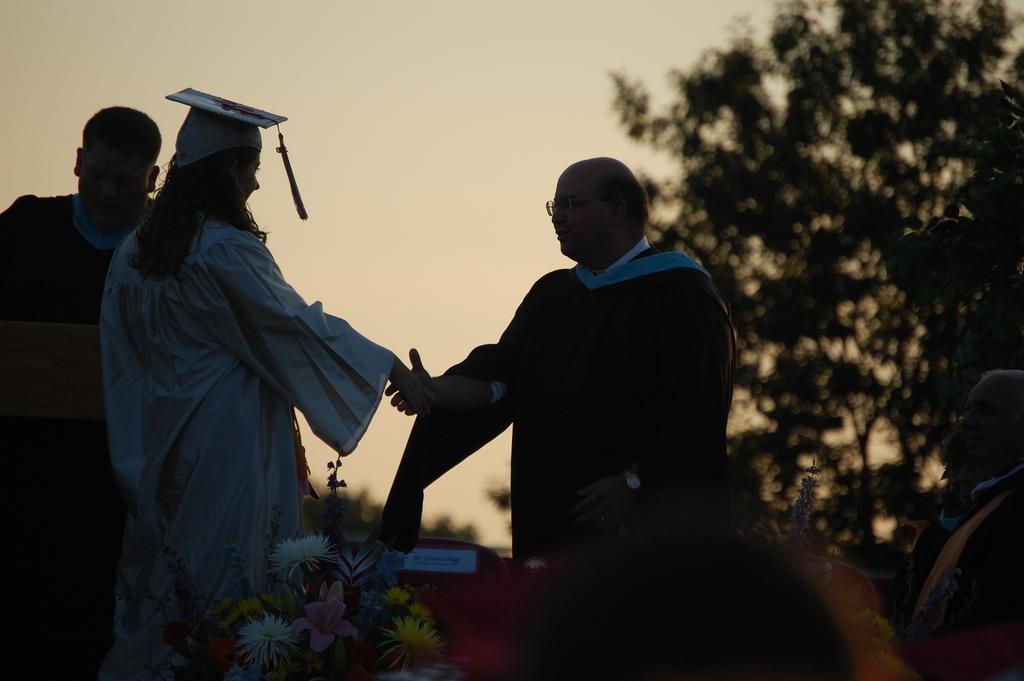How would you summarize this image in a sentence or two? In this image we can see one man standing and holding an object on the left side of the image. There are two persons standing on the right side of the image, one black object looks like a person's head on the bottom of the image, some flowers, one sticker with text attached to the object, some trees, bottom of the image is dark, two persons standing and handshaking in the middle of the image. There is the sky in the background. 